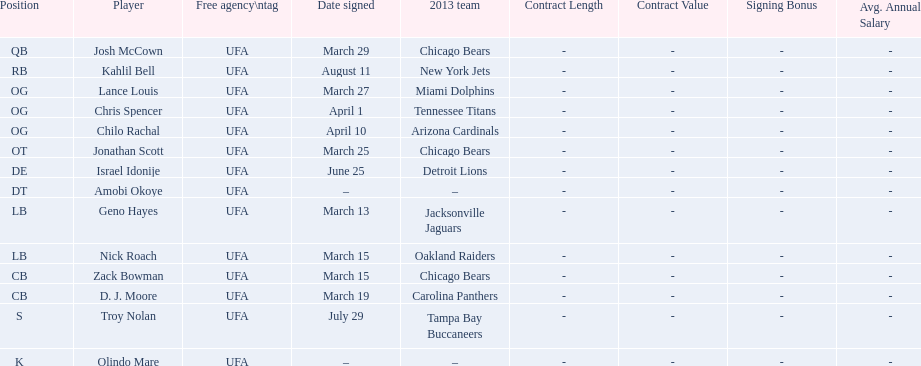What are all the dates signed? March 29, August 11, March 27, April 1, April 10, March 25, June 25, March 13, March 15, March 15, March 19, July 29. Which of these are duplicates? March 15, March 15. Who has the same one as nick roach? Zack Bowman. 